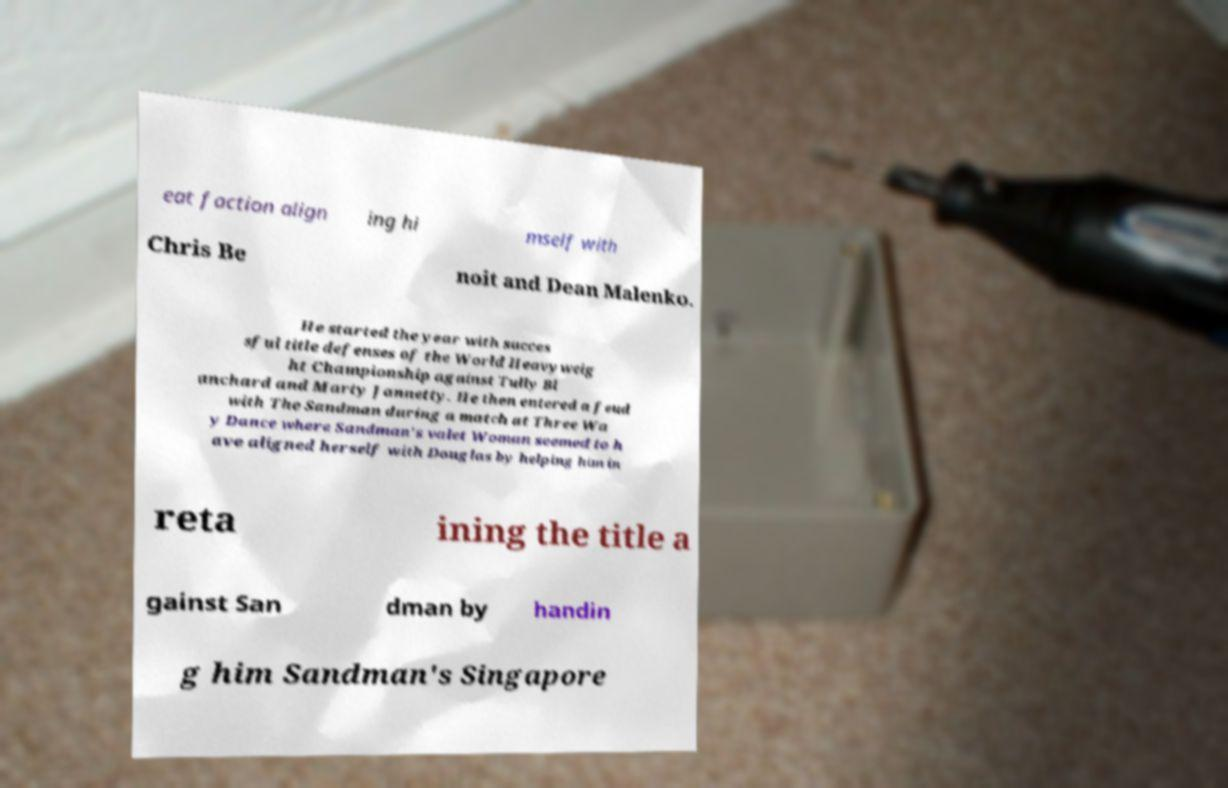Could you extract and type out the text from this image? eat faction align ing hi mself with Chris Be noit and Dean Malenko. He started the year with succes sful title defenses of the World Heavyweig ht Championship against Tully Bl anchard and Marty Jannetty. He then entered a feud with The Sandman during a match at Three Wa y Dance where Sandman's valet Woman seemed to h ave aligned herself with Douglas by helping him in reta ining the title a gainst San dman by handin g him Sandman's Singapore 